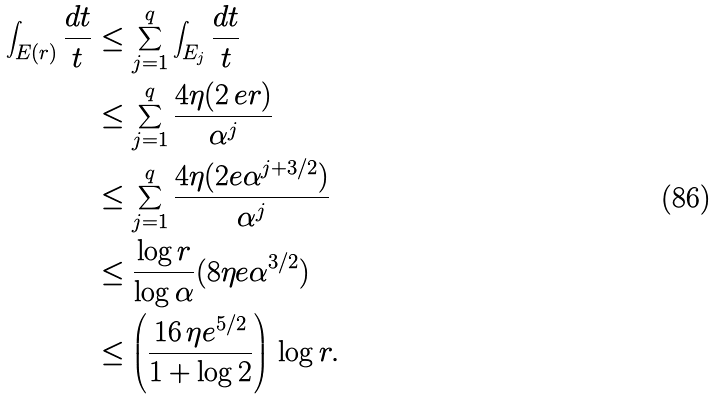<formula> <loc_0><loc_0><loc_500><loc_500>\int _ { E ( r ) } \frac { d t } { t } & \leq \sum _ { j = 1 } ^ { q } \int _ { E _ { j } } \frac { d t } { t } \\ & \leq \sum _ { j = 1 } ^ { q } \frac { 4 \eta ( 2 \, e r ) } { \alpha ^ { j } } \\ & \leq \sum _ { j = 1 } ^ { q } \frac { 4 \eta ( 2 e \alpha ^ { j + 3 / 2 } ) } { \alpha ^ { j } } \\ & \leq \frac { \log r } { \log \alpha } ( 8 \eta e \alpha ^ { 3 / 2 } ) \\ & \leq \left ( \frac { 1 6 \, \eta e ^ { 5 / 2 } } { 1 + \log 2 } \right ) \, \log r .</formula> 